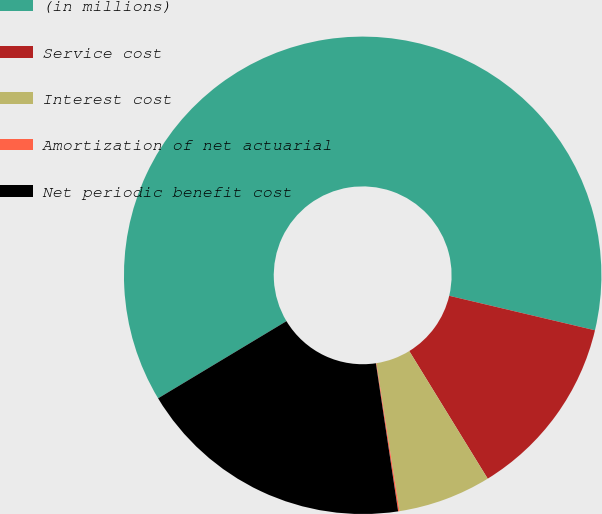Convert chart to OTSL. <chart><loc_0><loc_0><loc_500><loc_500><pie_chart><fcel>(in millions)<fcel>Service cost<fcel>Interest cost<fcel>Amortization of net actuarial<fcel>Net periodic benefit cost<nl><fcel>62.32%<fcel>12.53%<fcel>6.31%<fcel>0.09%<fcel>18.76%<nl></chart> 